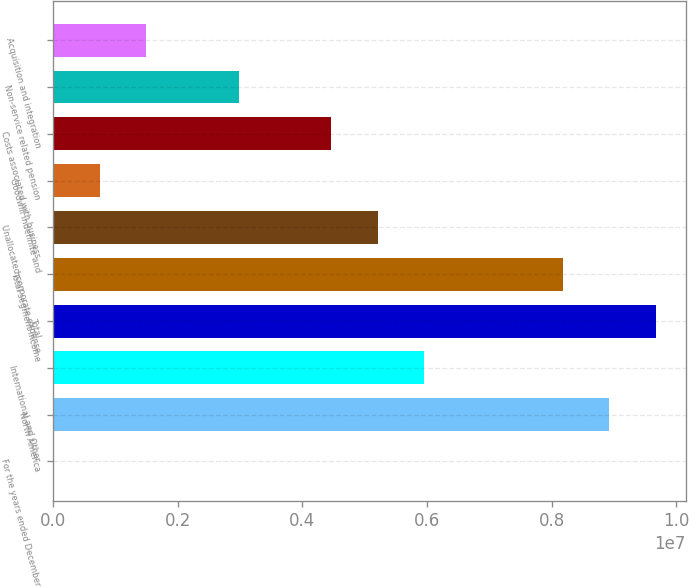Convert chart. <chart><loc_0><loc_0><loc_500><loc_500><bar_chart><fcel>For the years ended December<fcel>North America<fcel>International and Other<fcel>Total<fcel>Total segment income<fcel>Unallocated corporate expense<fcel>Goodwill indefinite and<fcel>Costs associated with business<fcel>Non-service related pension<fcel>Acquisition and integration<nl><fcel>2016<fcel>8.92781e+06<fcel>5.95255e+06<fcel>9.67163e+06<fcel>8.184e+06<fcel>5.20873e+06<fcel>745832<fcel>4.46492e+06<fcel>2.97728e+06<fcel>1.48965e+06<nl></chart> 